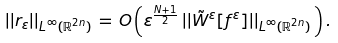Convert formula to latex. <formula><loc_0><loc_0><loc_500><loc_500>| | r _ { \varepsilon } | | _ { L ^ { \infty } ( \mathbb { R } ^ { 2 n } ) } \, = \, O \left ( \varepsilon ^ { \frac { N + 1 } { 2 } } \, | | \tilde { W } ^ { \varepsilon } [ f ^ { \varepsilon } ] | | _ { L ^ { \infty } ( \mathbb { R } ^ { 2 n } ) } \, \right ) .</formula> 